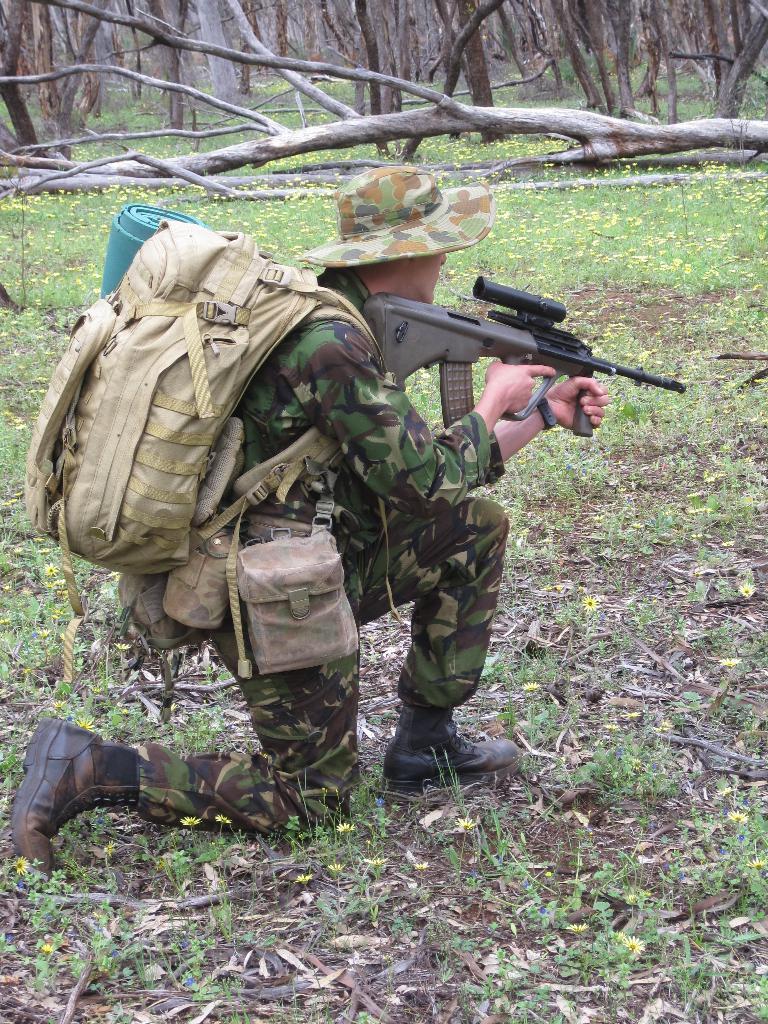What is the main subject of the image? There is a person in the image. What is the person carrying in the image? The person is carrying a bag. What is the person holding in the image? The person is holding a gun. What type of vegetation is present on the ground in the image? The ground is covered with grass and plants. What can be seen in the background of the image? There are trees visible in the image. What type of shoe is the hen wearing in the image? There is no hen or shoe present in the image. How many pies are visible on the ground in the image? There are no pies present in the image. 